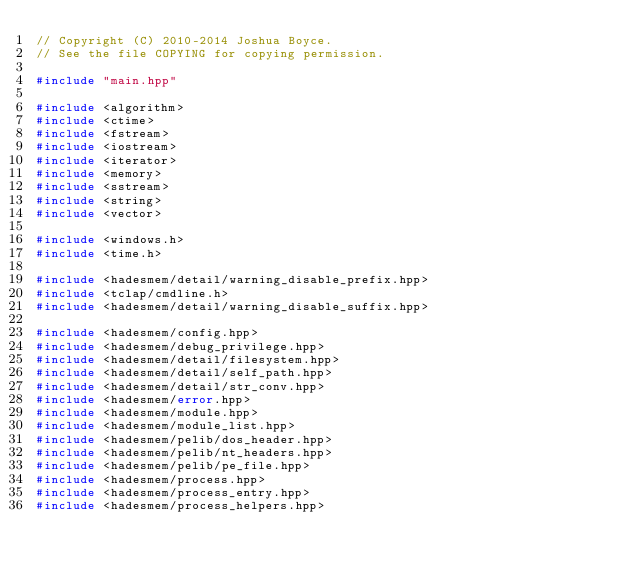<code> <loc_0><loc_0><loc_500><loc_500><_C++_>// Copyright (C) 2010-2014 Joshua Boyce.
// See the file COPYING for copying permission.

#include "main.hpp"

#include <algorithm>
#include <ctime>
#include <fstream>
#include <iostream>
#include <iterator>
#include <memory>
#include <sstream>
#include <string>
#include <vector>

#include <windows.h>
#include <time.h>

#include <hadesmem/detail/warning_disable_prefix.hpp>
#include <tclap/cmdline.h>
#include <hadesmem/detail/warning_disable_suffix.hpp>

#include <hadesmem/config.hpp>
#include <hadesmem/debug_privilege.hpp>
#include <hadesmem/detail/filesystem.hpp>
#include <hadesmem/detail/self_path.hpp>
#include <hadesmem/detail/str_conv.hpp>
#include <hadesmem/error.hpp>
#include <hadesmem/module.hpp>
#include <hadesmem/module_list.hpp>
#include <hadesmem/pelib/dos_header.hpp>
#include <hadesmem/pelib/nt_headers.hpp>
#include <hadesmem/pelib/pe_file.hpp>
#include <hadesmem/process.hpp>
#include <hadesmem/process_entry.hpp>
#include <hadesmem/process_helpers.hpp></code> 